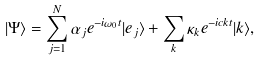Convert formula to latex. <formula><loc_0><loc_0><loc_500><loc_500>| \Psi \rangle = \sum _ { j = 1 } ^ { N } \alpha _ { j } e ^ { - i \omega _ { 0 } t } | e _ { j } \rangle + \sum _ { k } \kappa _ { k } e ^ { - i c k t } | { k } \rangle ,</formula> 